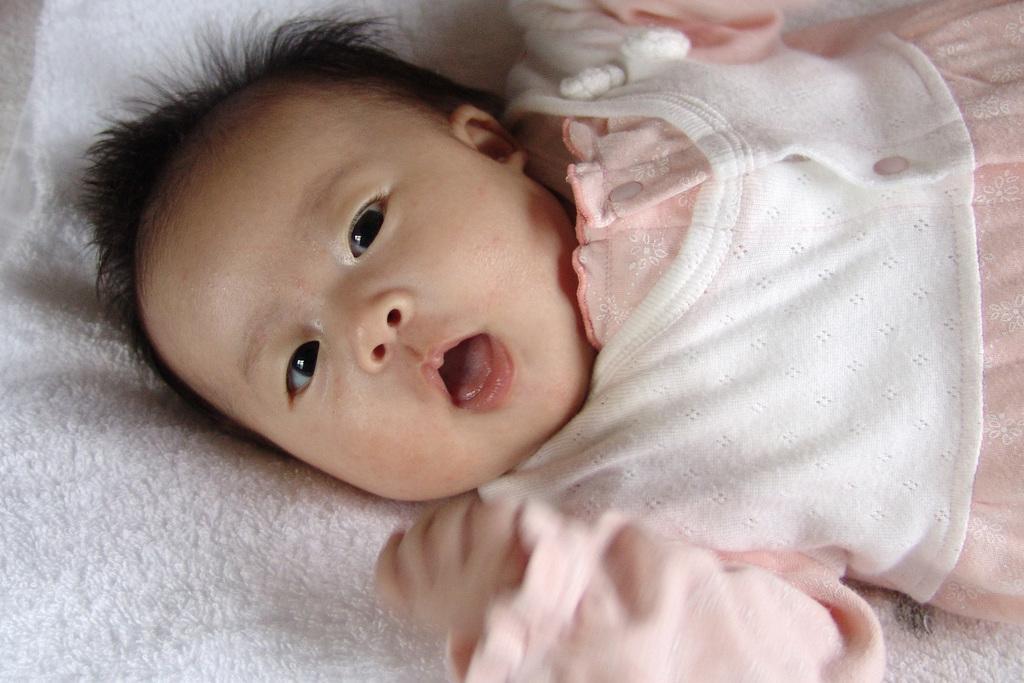Please provide a concise description of this image. In the center of this picture we can see an Infant lying on a white color object. 